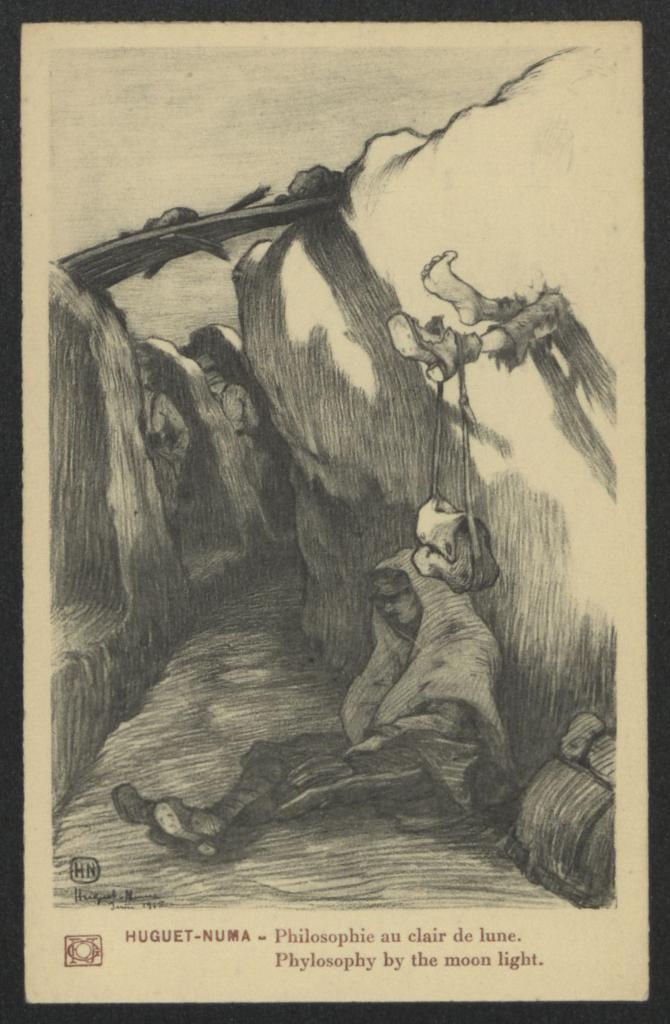Describe this image in one or two sentences. In this image we can see drawing of a person sitting on the ground. On the sides there are walls. Also there is a bridge across the walls. And we can see legs of a person. On the leg there is a bag hanged. At the bottom something is written. 